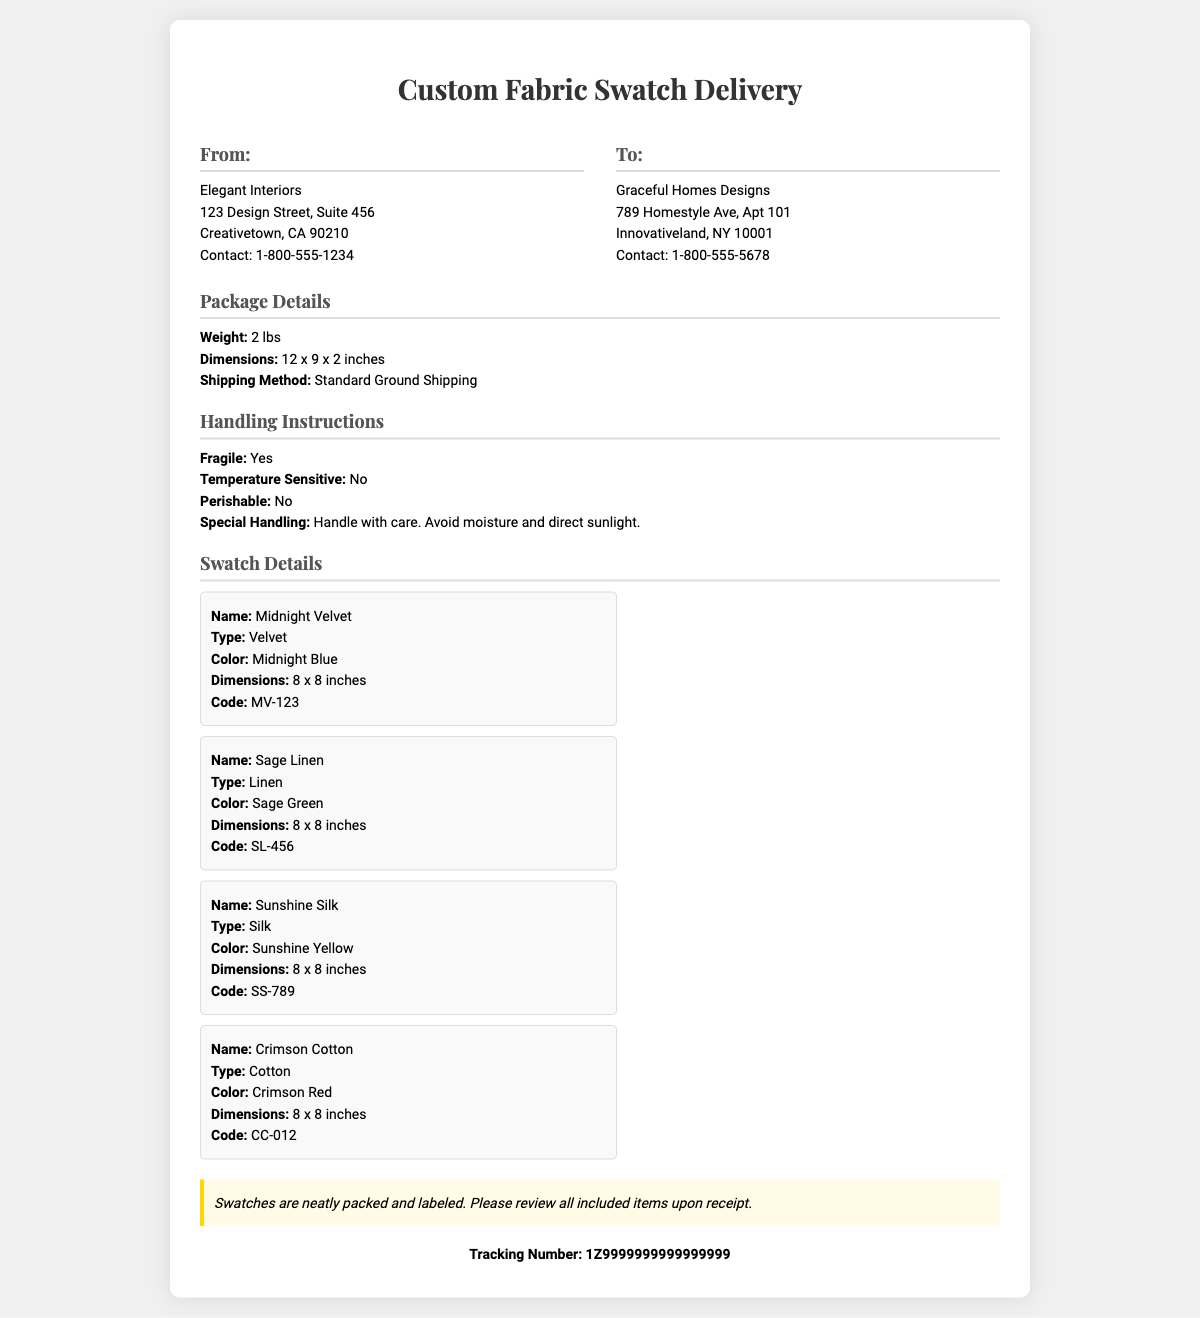What is the sender's name? The sender's name is listed in the document as "Elegant Interiors."
Answer: Elegant Interiors What is the recipient's contact number? The recipient's contact number is provided in the document, which is "1-800-555-5678."
Answer: 1-800-555-5678 What is the weight of the package? The document states the weight of the package is "2 lbs."
Answer: 2 lbs How should the package be handled? The handling instructions indicate that the package should be "Handle with care."
Answer: Handle with care What type of fabric is the first swatch? The first swatch's type is "Velvet," as described in the document.
Answer: Velvet What color is the third fabric swatch? The document notes that the third swatch is "Sunshine Yellow."
Answer: Sunshine Yellow What are the dimensions of the package? The dimensions of the package are specified as "12 x 9 x 2 inches."
Answer: 12 x 9 x 2 inches How many swatches are included in the delivery? The document lists four separate fabric swatches, indicating the quantity included.
Answer: Four What is the tracking number provided? The document contains a tracking number, which is "1Z9999999999999999."
Answer: 1Z9999999999999999 